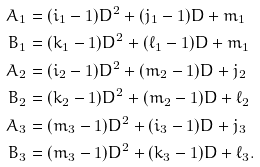<formula> <loc_0><loc_0><loc_500><loc_500>A _ { 1 } & = ( i _ { 1 } - 1 ) D ^ { 2 } + ( j _ { 1 } - 1 ) D + m _ { 1 } \\ B _ { 1 } & = ( k _ { 1 } - 1 ) D ^ { 2 } + ( \ell _ { 1 } - 1 ) D + m _ { 1 } \\ A _ { 2 } & = ( i _ { 2 } - 1 ) D ^ { 2 } + ( m _ { 2 } - 1 ) D + j _ { 2 } \\ B _ { 2 } & = ( k _ { 2 } - 1 ) D ^ { 2 } + ( m _ { 2 } - 1 ) D + \ell _ { 2 } \\ A _ { 3 } & = ( m _ { 3 } - 1 ) D ^ { 2 } + ( i _ { 3 } - 1 ) D + j _ { 3 } \\ B _ { 3 } & = ( m _ { 3 } - 1 ) D ^ { 2 } + ( k _ { 3 } - 1 ) D + \ell _ { 3 } .</formula> 